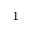Convert formula to latex. <formula><loc_0><loc_0><loc_500><loc_500>^ { 1 }</formula> 